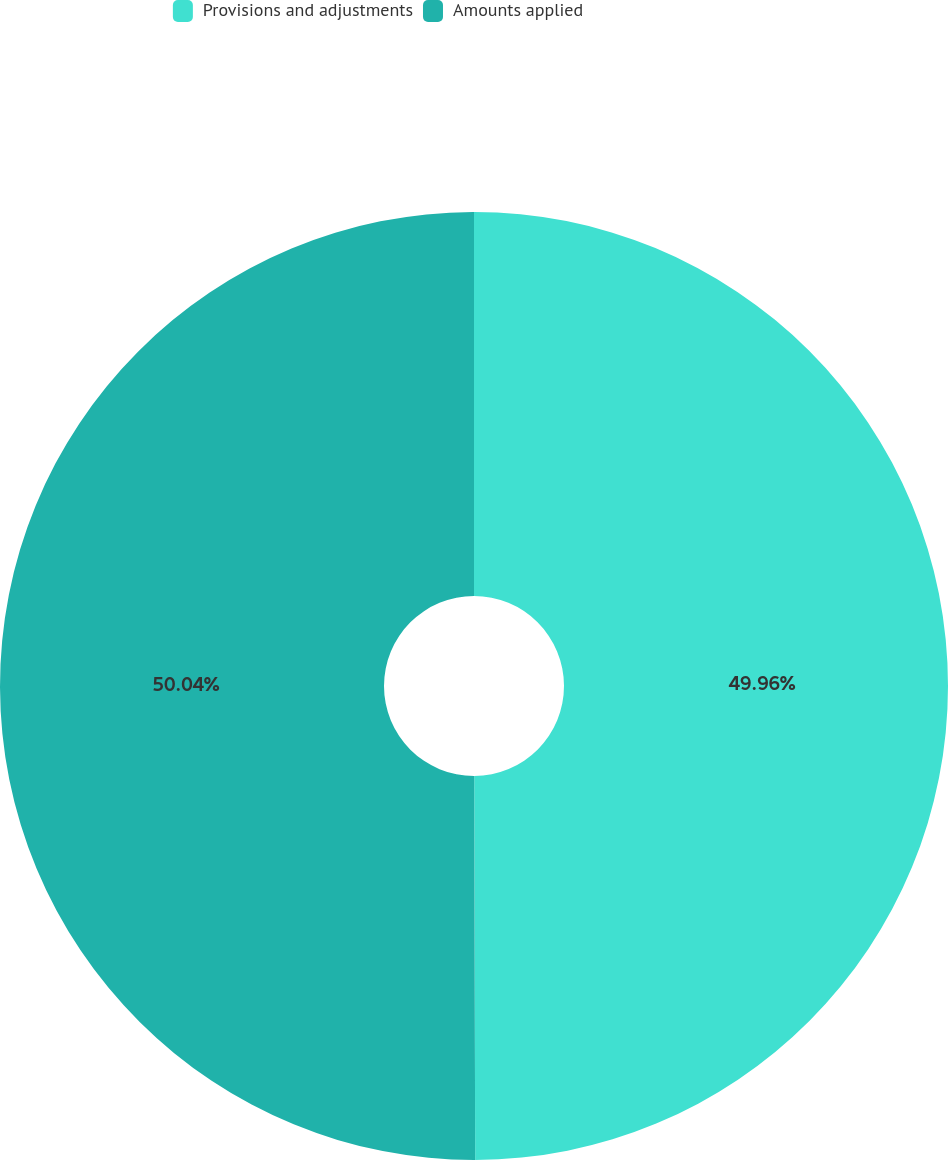Convert chart to OTSL. <chart><loc_0><loc_0><loc_500><loc_500><pie_chart><fcel>Provisions and adjustments<fcel>Amounts applied<nl><fcel>49.96%<fcel>50.04%<nl></chart> 